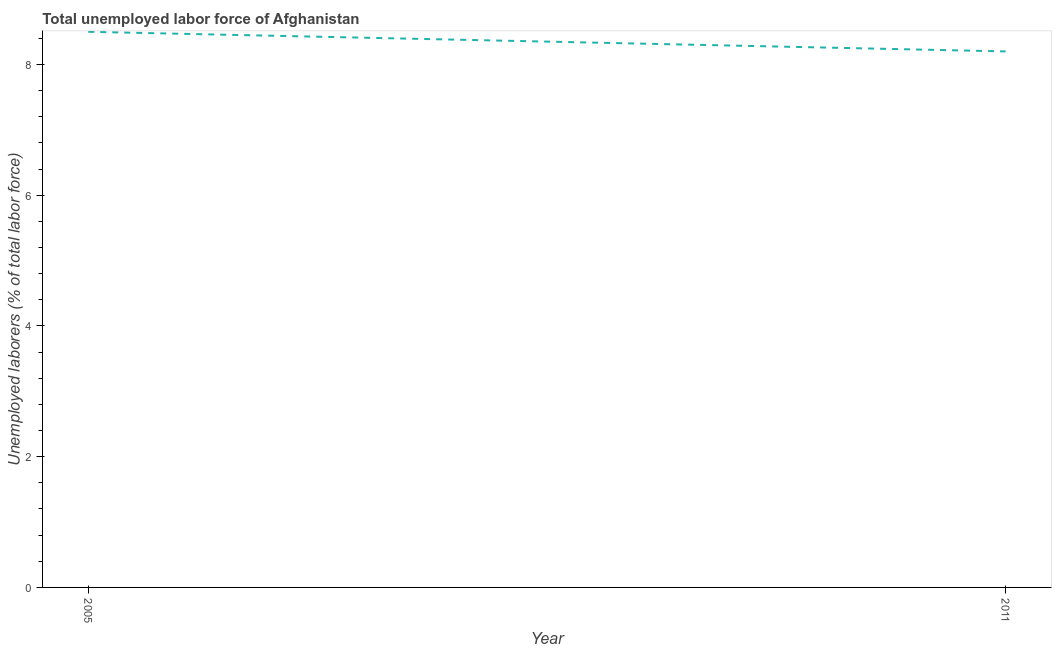What is the total unemployed labour force in 2011?
Offer a very short reply. 8.2. Across all years, what is the minimum total unemployed labour force?
Give a very brief answer. 8.2. In which year was the total unemployed labour force maximum?
Provide a short and direct response. 2005. In which year was the total unemployed labour force minimum?
Your answer should be very brief. 2011. What is the sum of the total unemployed labour force?
Your answer should be very brief. 16.7. What is the difference between the total unemployed labour force in 2005 and 2011?
Provide a short and direct response. 0.3. What is the average total unemployed labour force per year?
Ensure brevity in your answer.  8.35. What is the median total unemployed labour force?
Your answer should be very brief. 8.35. What is the ratio of the total unemployed labour force in 2005 to that in 2011?
Make the answer very short. 1.04. How many years are there in the graph?
Provide a succinct answer. 2. What is the difference between two consecutive major ticks on the Y-axis?
Ensure brevity in your answer.  2. Does the graph contain any zero values?
Make the answer very short. No. What is the title of the graph?
Offer a terse response. Total unemployed labor force of Afghanistan. What is the label or title of the Y-axis?
Offer a terse response. Unemployed laborers (% of total labor force). What is the Unemployed laborers (% of total labor force) of 2005?
Provide a short and direct response. 8.5. What is the Unemployed laborers (% of total labor force) of 2011?
Your answer should be compact. 8.2. What is the difference between the Unemployed laborers (% of total labor force) in 2005 and 2011?
Your answer should be very brief. 0.3. What is the ratio of the Unemployed laborers (% of total labor force) in 2005 to that in 2011?
Your response must be concise. 1.04. 